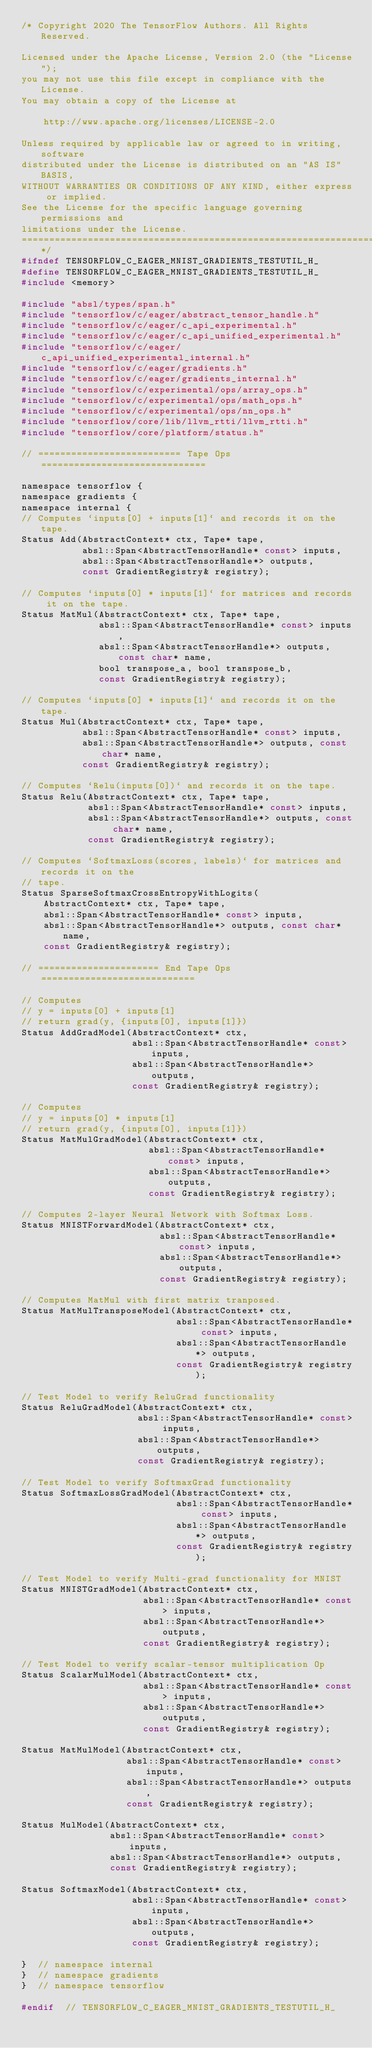Convert code to text. <code><loc_0><loc_0><loc_500><loc_500><_C_>/* Copyright 2020 The TensorFlow Authors. All Rights Reserved.

Licensed under the Apache License, Version 2.0 (the "License");
you may not use this file except in compliance with the License.
You may obtain a copy of the License at

    http://www.apache.org/licenses/LICENSE-2.0

Unless required by applicable law or agreed to in writing, software
distributed under the License is distributed on an "AS IS" BASIS,
WITHOUT WARRANTIES OR CONDITIONS OF ANY KIND, either express or implied.
See the License for the specific language governing permissions and
limitations under the License.
==============================================================================*/
#ifndef TENSORFLOW_C_EAGER_MNIST_GRADIENTS_TESTUTIL_H_
#define TENSORFLOW_C_EAGER_MNIST_GRADIENTS_TESTUTIL_H_
#include <memory>

#include "absl/types/span.h"
#include "tensorflow/c/eager/abstract_tensor_handle.h"
#include "tensorflow/c/eager/c_api_experimental.h"
#include "tensorflow/c/eager/c_api_unified_experimental.h"
#include "tensorflow/c/eager/c_api_unified_experimental_internal.h"
#include "tensorflow/c/eager/gradients.h"
#include "tensorflow/c/eager/gradients_internal.h"
#include "tensorflow/c/experimental/ops/array_ops.h"
#include "tensorflow/c/experimental/ops/math_ops.h"
#include "tensorflow/c/experimental/ops/nn_ops.h"
#include "tensorflow/core/lib/llvm_rtti/llvm_rtti.h"
#include "tensorflow/core/platform/status.h"

// ========================== Tape Ops ==============================

namespace tensorflow {
namespace gradients {
namespace internal {
// Computes `inputs[0] + inputs[1]` and records it on the tape.
Status Add(AbstractContext* ctx, Tape* tape,
           absl::Span<AbstractTensorHandle* const> inputs,
           absl::Span<AbstractTensorHandle*> outputs,
           const GradientRegistry& registry);

// Computes `inputs[0] * inputs[1]` for matrices and records it on the tape.
Status MatMul(AbstractContext* ctx, Tape* tape,
              absl::Span<AbstractTensorHandle* const> inputs,
              absl::Span<AbstractTensorHandle*> outputs, const char* name,
              bool transpose_a, bool transpose_b,
              const GradientRegistry& registry);

// Computes `inputs[0] * inputs[1]` and records it on the tape.
Status Mul(AbstractContext* ctx, Tape* tape,
           absl::Span<AbstractTensorHandle* const> inputs,
           absl::Span<AbstractTensorHandle*> outputs, const char* name,
           const GradientRegistry& registry);

// Computes `Relu(inputs[0])` and records it on the tape.
Status Relu(AbstractContext* ctx, Tape* tape,
            absl::Span<AbstractTensorHandle* const> inputs,
            absl::Span<AbstractTensorHandle*> outputs, const char* name,
            const GradientRegistry& registry);

// Computes `SoftmaxLoss(scores, labels)` for matrices and records it on the
// tape.
Status SparseSoftmaxCrossEntropyWithLogits(
    AbstractContext* ctx, Tape* tape,
    absl::Span<AbstractTensorHandle* const> inputs,
    absl::Span<AbstractTensorHandle*> outputs, const char* name,
    const GradientRegistry& registry);

// ====================== End Tape Ops ============================

// Computes
// y = inputs[0] + inputs[1]
// return grad(y, {inputs[0], inputs[1]})
Status AddGradModel(AbstractContext* ctx,
                    absl::Span<AbstractTensorHandle* const> inputs,
                    absl::Span<AbstractTensorHandle*> outputs,
                    const GradientRegistry& registry);

// Computes
// y = inputs[0] * inputs[1]
// return grad(y, {inputs[0], inputs[1]})
Status MatMulGradModel(AbstractContext* ctx,
                       absl::Span<AbstractTensorHandle* const> inputs,
                       absl::Span<AbstractTensorHandle*> outputs,
                       const GradientRegistry& registry);

// Computes 2-layer Neural Network with Softmax Loss.
Status MNISTForwardModel(AbstractContext* ctx,
                         absl::Span<AbstractTensorHandle* const> inputs,
                         absl::Span<AbstractTensorHandle*> outputs,
                         const GradientRegistry& registry);

// Computes MatMul with first matrix tranposed.
Status MatMulTransposeModel(AbstractContext* ctx,
                            absl::Span<AbstractTensorHandle* const> inputs,
                            absl::Span<AbstractTensorHandle*> outputs,
                            const GradientRegistry& registry);

// Test Model to verify ReluGrad functionality
Status ReluGradModel(AbstractContext* ctx,
                     absl::Span<AbstractTensorHandle* const> inputs,
                     absl::Span<AbstractTensorHandle*> outputs,
                     const GradientRegistry& registry);

// Test Model to verify SoftmaxGrad functionality
Status SoftmaxLossGradModel(AbstractContext* ctx,
                            absl::Span<AbstractTensorHandle* const> inputs,
                            absl::Span<AbstractTensorHandle*> outputs,
                            const GradientRegistry& registry);

// Test Model to verify Multi-grad functionality for MNIST
Status MNISTGradModel(AbstractContext* ctx,
                      absl::Span<AbstractTensorHandle* const> inputs,
                      absl::Span<AbstractTensorHandle*> outputs,
                      const GradientRegistry& registry);

// Test Model to verify scalar-tensor multiplication Op
Status ScalarMulModel(AbstractContext* ctx,
                      absl::Span<AbstractTensorHandle* const> inputs,
                      absl::Span<AbstractTensorHandle*> outputs,
                      const GradientRegistry& registry);

Status MatMulModel(AbstractContext* ctx,
                   absl::Span<AbstractTensorHandle* const> inputs,
                   absl::Span<AbstractTensorHandle*> outputs,
                   const GradientRegistry& registry);

Status MulModel(AbstractContext* ctx,
                absl::Span<AbstractTensorHandle* const> inputs,
                absl::Span<AbstractTensorHandle*> outputs,
                const GradientRegistry& registry);

Status SoftmaxModel(AbstractContext* ctx,
                    absl::Span<AbstractTensorHandle* const> inputs,
                    absl::Span<AbstractTensorHandle*> outputs,
                    const GradientRegistry& registry);

}  // namespace internal
}  // namespace gradients
}  // namespace tensorflow

#endif  // TENSORFLOW_C_EAGER_MNIST_GRADIENTS_TESTUTIL_H_
</code> 